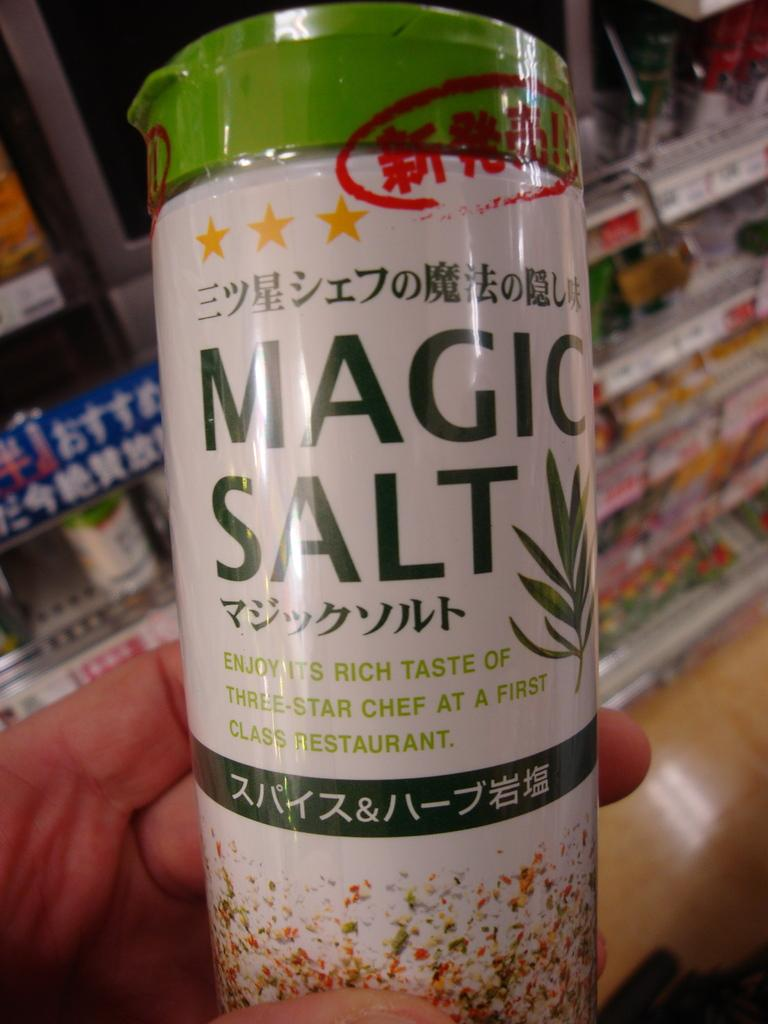<image>
Write a terse but informative summary of the picture. A bottle of Magic Salt, stating that it can elevate your food at home to make it taste like something from a first class restaurant. 